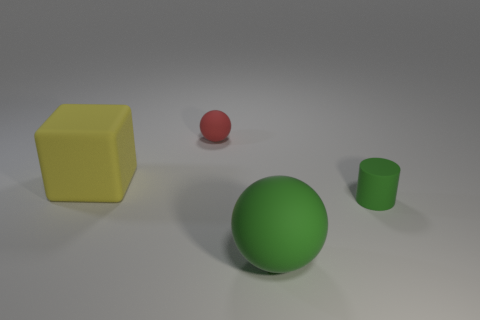There is a tiny thing that is right of the large green ball; are there any red matte balls that are in front of it?
Your answer should be compact. No. What number of objects are green things behind the big green sphere or big metallic balls?
Provide a succinct answer. 1. What number of tiny brown matte spheres are there?
Ensure brevity in your answer.  0. The yellow object that is the same material as the red sphere is what shape?
Offer a very short reply. Cube. There is a thing on the right side of the rubber ball that is right of the tiny rubber sphere; how big is it?
Make the answer very short. Small. What number of objects are yellow objects that are to the left of the small green matte object or things that are to the left of the small rubber sphere?
Offer a terse response. 1. Are there fewer gray matte cylinders than small red matte things?
Ensure brevity in your answer.  Yes. How many things are yellow things or red spheres?
Your answer should be compact. 2. Do the tiny red rubber object and the big yellow thing have the same shape?
Keep it short and to the point. No. Are there any other things that have the same material as the red ball?
Give a very brief answer. Yes. 